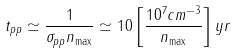<formula> <loc_0><loc_0><loc_500><loc_500>t _ { p p } \simeq \frac { 1 } { \sigma _ { p p } n _ { \max } } \simeq 1 0 \left [ \frac { 1 0 ^ { 7 } c m ^ { - 3 } } { n _ { \max } } \right ] y r</formula> 